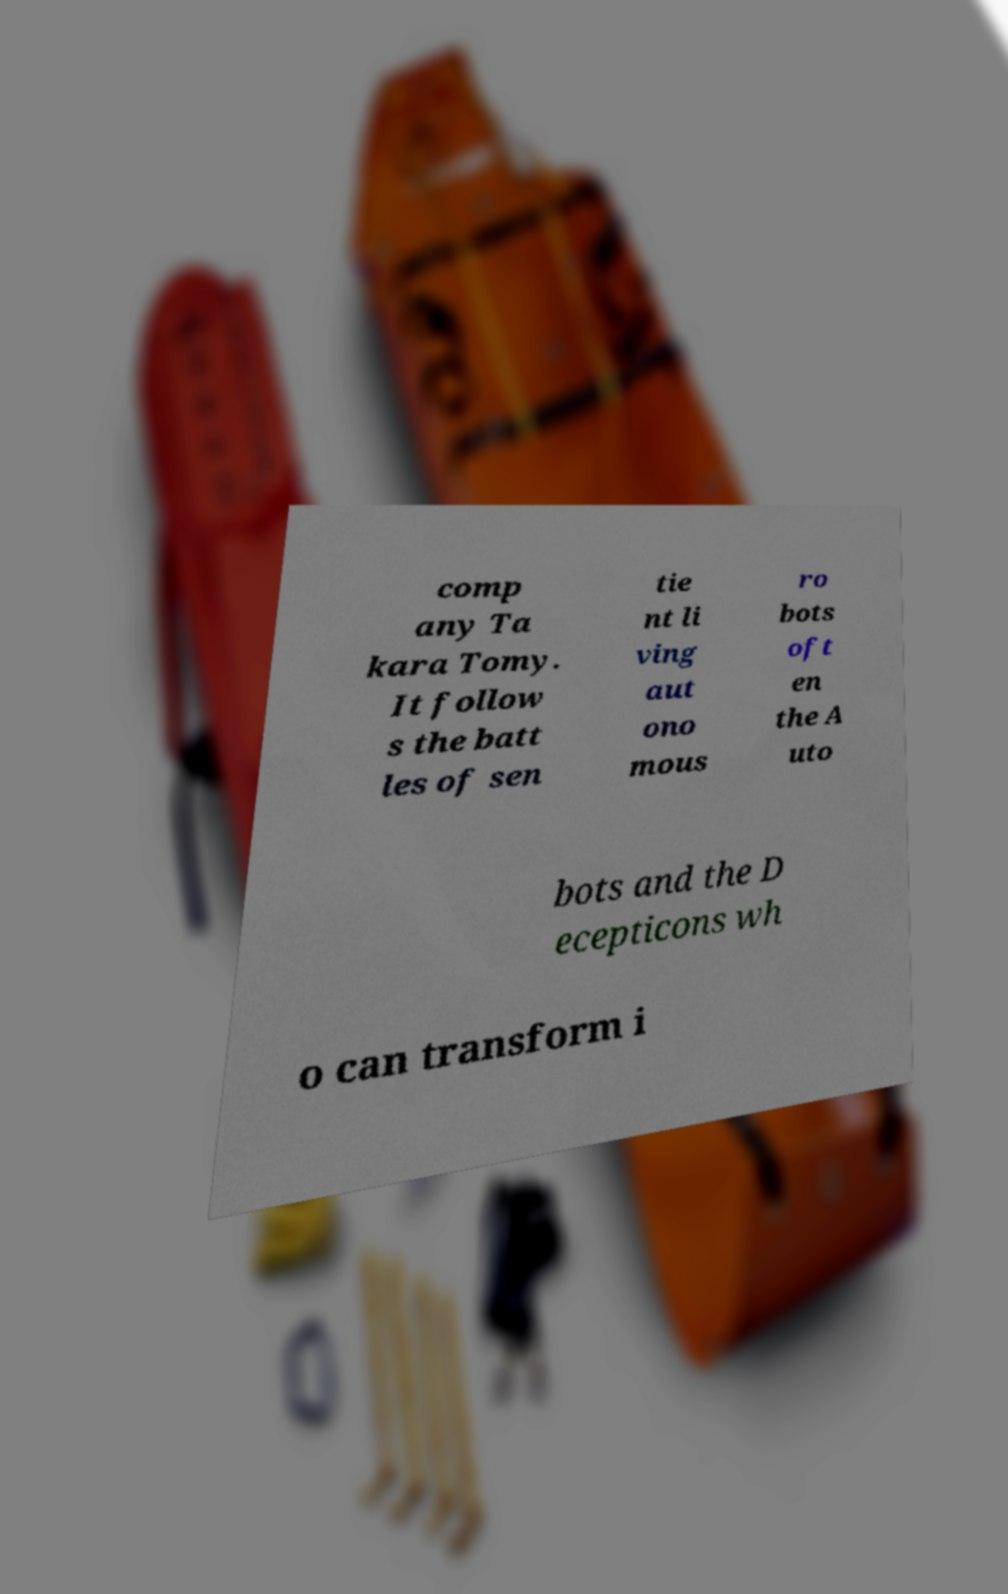What messages or text are displayed in this image? I need them in a readable, typed format. comp any Ta kara Tomy. It follow s the batt les of sen tie nt li ving aut ono mous ro bots oft en the A uto bots and the D ecepticons wh o can transform i 